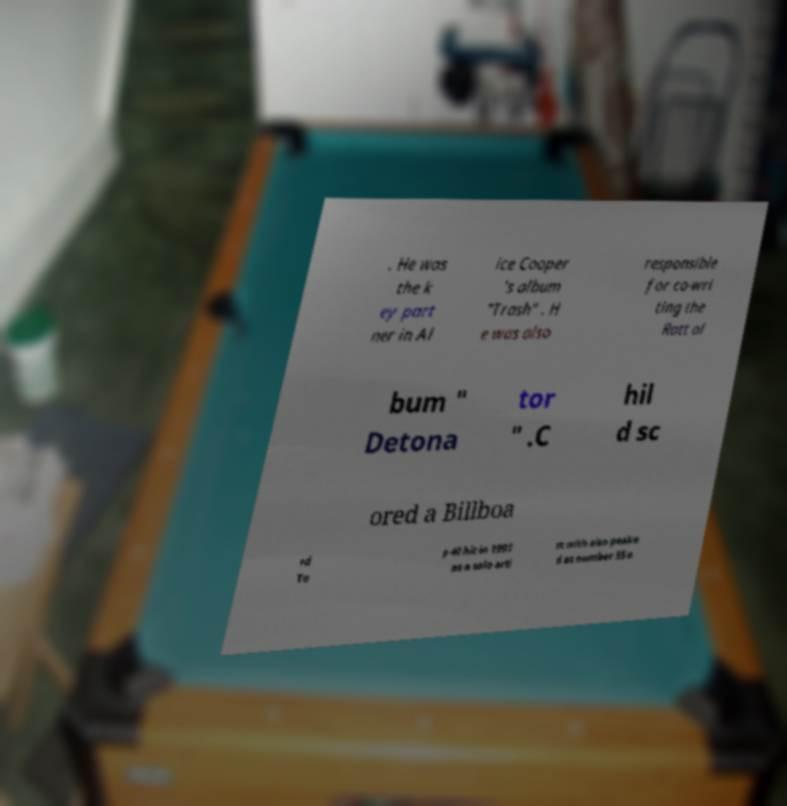Please read and relay the text visible in this image. What does it say? . He was the k ey part ner in Al ice Cooper 's album "Trash" . H e was also responsible for co-wri ting the Ratt al bum " Detona tor " .C hil d sc ored a Billboa rd To p 40 hit in 1991 as a solo arti st with also peake d at number 55 o 